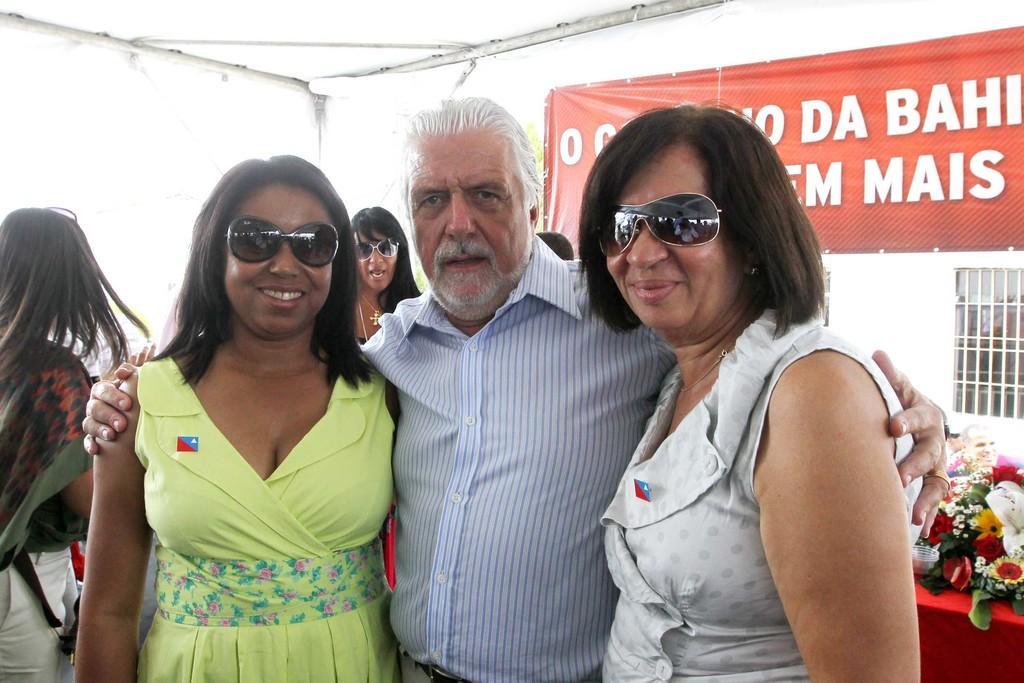In one or two sentences, can you explain what this image depicts? This picture seems to be clicked inside the room. In the center we can see a man wearing blue color shirt and standing and we can see the women wearing dresses, goggles and standing. In the background we can see the flowers, leaves and group of persons and we can see the text on the banner and we can see the window, metal rods and some other objects. 